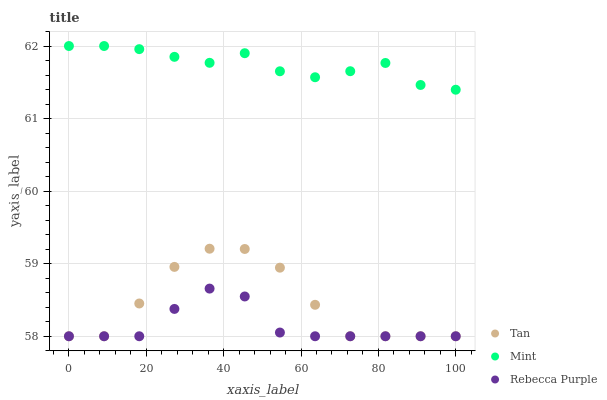Does Rebecca Purple have the minimum area under the curve?
Answer yes or no. Yes. Does Mint have the maximum area under the curve?
Answer yes or no. Yes. Does Mint have the minimum area under the curve?
Answer yes or no. No. Does Rebecca Purple have the maximum area under the curve?
Answer yes or no. No. Is Mint the smoothest?
Answer yes or no. Yes. Is Tan the roughest?
Answer yes or no. Yes. Is Rebecca Purple the smoothest?
Answer yes or no. No. Is Rebecca Purple the roughest?
Answer yes or no. No. Does Tan have the lowest value?
Answer yes or no. Yes. Does Mint have the lowest value?
Answer yes or no. No. Does Mint have the highest value?
Answer yes or no. Yes. Does Rebecca Purple have the highest value?
Answer yes or no. No. Is Tan less than Mint?
Answer yes or no. Yes. Is Mint greater than Rebecca Purple?
Answer yes or no. Yes. Does Rebecca Purple intersect Tan?
Answer yes or no. Yes. Is Rebecca Purple less than Tan?
Answer yes or no. No. Is Rebecca Purple greater than Tan?
Answer yes or no. No. Does Tan intersect Mint?
Answer yes or no. No. 